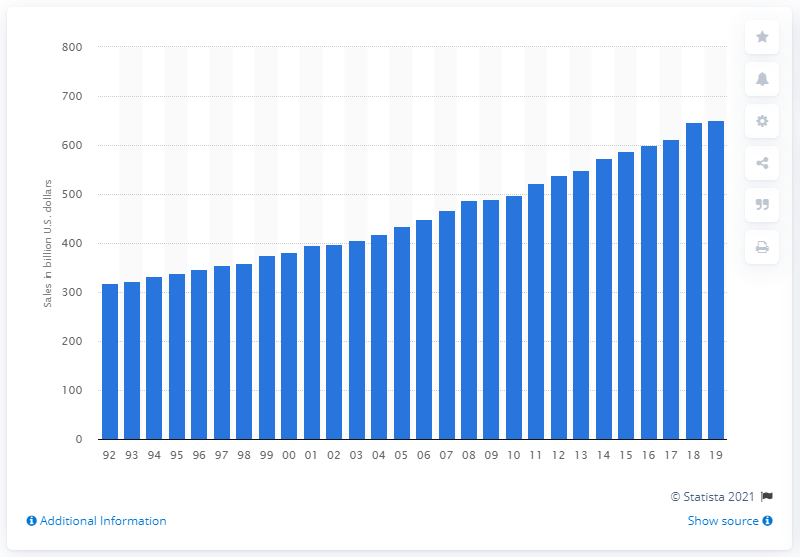Indicate a few pertinent items in this graphic. In 2019, the sales of supermarkets and grocery stores amounted to a total of 650.97 dollars. 